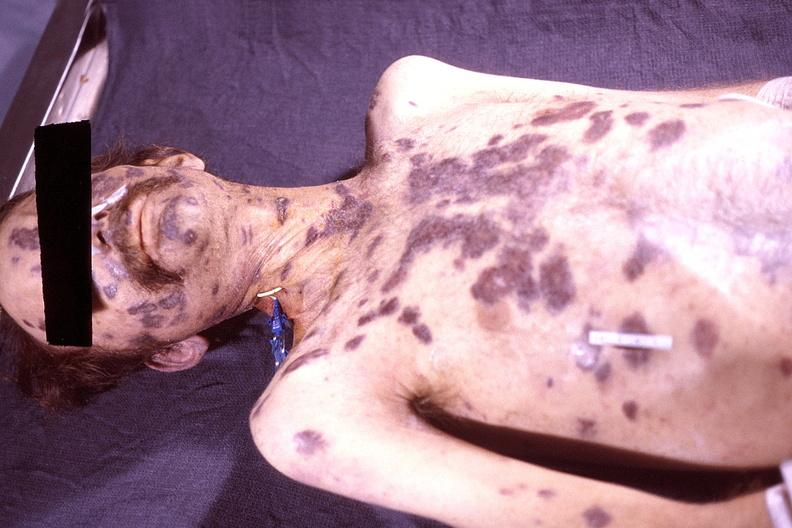what does this image show?
Answer the question using a single word or phrase. Skin 